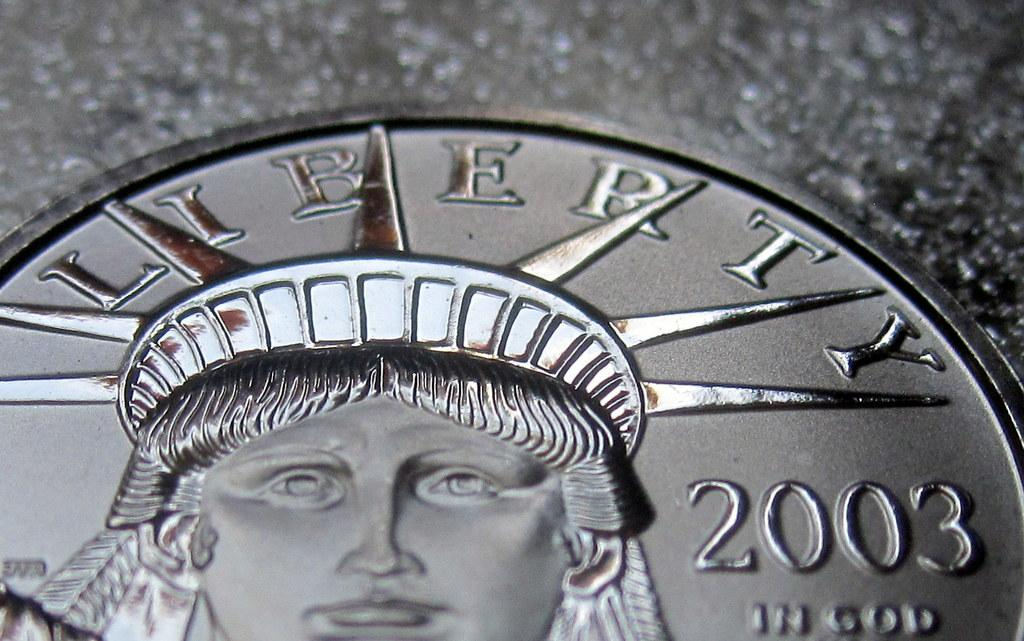<image>
Render a clear and concise summary of the photo. A 2003 coin displays the Statue of Liberty 